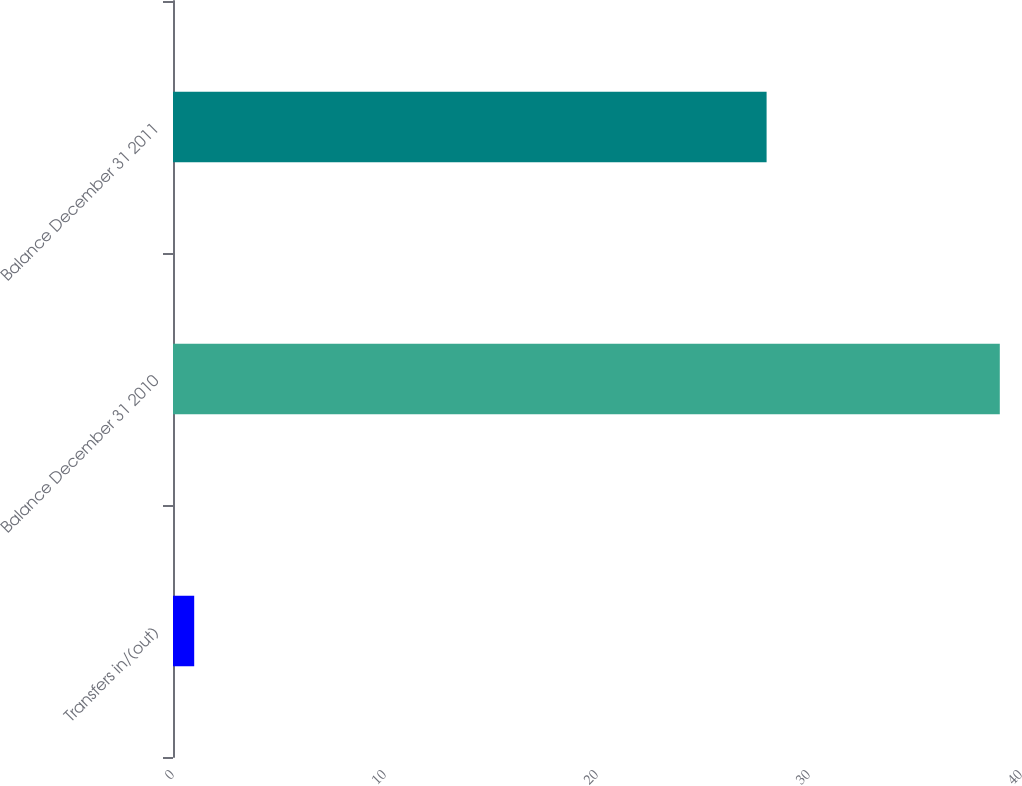Convert chart. <chart><loc_0><loc_0><loc_500><loc_500><bar_chart><fcel>Transfers in/(out)<fcel>Balance December 31 2010<fcel>Balance December 31 2011<nl><fcel>1<fcel>39<fcel>28<nl></chart> 